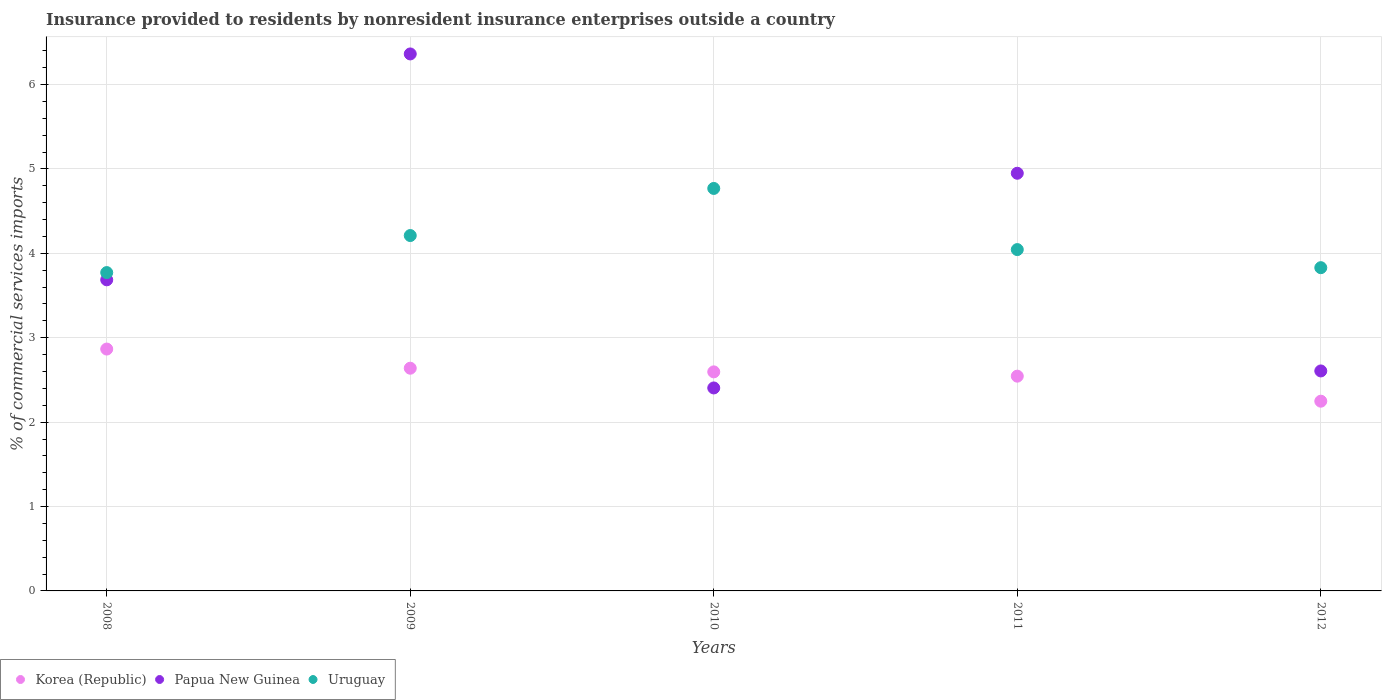How many different coloured dotlines are there?
Give a very brief answer. 3. What is the Insurance provided to residents in Korea (Republic) in 2011?
Provide a succinct answer. 2.54. Across all years, what is the maximum Insurance provided to residents in Papua New Guinea?
Offer a very short reply. 6.36. Across all years, what is the minimum Insurance provided to residents in Uruguay?
Offer a terse response. 3.77. In which year was the Insurance provided to residents in Uruguay maximum?
Make the answer very short. 2010. In which year was the Insurance provided to residents in Papua New Guinea minimum?
Ensure brevity in your answer.  2010. What is the total Insurance provided to residents in Papua New Guinea in the graph?
Offer a very short reply. 20.01. What is the difference between the Insurance provided to residents in Uruguay in 2009 and that in 2010?
Your answer should be compact. -0.56. What is the difference between the Insurance provided to residents in Korea (Republic) in 2008 and the Insurance provided to residents in Papua New Guinea in 2012?
Offer a very short reply. 0.26. What is the average Insurance provided to residents in Uruguay per year?
Provide a short and direct response. 4.13. In the year 2012, what is the difference between the Insurance provided to residents in Korea (Republic) and Insurance provided to residents in Uruguay?
Give a very brief answer. -1.58. What is the ratio of the Insurance provided to residents in Papua New Guinea in 2009 to that in 2010?
Provide a succinct answer. 2.65. Is the difference between the Insurance provided to residents in Korea (Republic) in 2009 and 2012 greater than the difference between the Insurance provided to residents in Uruguay in 2009 and 2012?
Offer a terse response. Yes. What is the difference between the highest and the second highest Insurance provided to residents in Papua New Guinea?
Keep it short and to the point. 1.41. What is the difference between the highest and the lowest Insurance provided to residents in Uruguay?
Your answer should be very brief. 1. In how many years, is the Insurance provided to residents in Papua New Guinea greater than the average Insurance provided to residents in Papua New Guinea taken over all years?
Your answer should be very brief. 2. Is the sum of the Insurance provided to residents in Korea (Republic) in 2009 and 2012 greater than the maximum Insurance provided to residents in Papua New Guinea across all years?
Ensure brevity in your answer.  No. What is the difference between two consecutive major ticks on the Y-axis?
Give a very brief answer. 1. Are the values on the major ticks of Y-axis written in scientific E-notation?
Ensure brevity in your answer.  No. Does the graph contain grids?
Offer a terse response. Yes. How many legend labels are there?
Offer a very short reply. 3. How are the legend labels stacked?
Ensure brevity in your answer.  Horizontal. What is the title of the graph?
Provide a succinct answer. Insurance provided to residents by nonresident insurance enterprises outside a country. Does "Sweden" appear as one of the legend labels in the graph?
Keep it short and to the point. No. What is the label or title of the X-axis?
Your response must be concise. Years. What is the label or title of the Y-axis?
Your answer should be compact. % of commercial services imports. What is the % of commercial services imports in Korea (Republic) in 2008?
Offer a very short reply. 2.87. What is the % of commercial services imports in Papua New Guinea in 2008?
Offer a very short reply. 3.69. What is the % of commercial services imports in Uruguay in 2008?
Offer a very short reply. 3.77. What is the % of commercial services imports in Korea (Republic) in 2009?
Give a very brief answer. 2.64. What is the % of commercial services imports in Papua New Guinea in 2009?
Your answer should be very brief. 6.36. What is the % of commercial services imports of Uruguay in 2009?
Your answer should be very brief. 4.21. What is the % of commercial services imports of Korea (Republic) in 2010?
Make the answer very short. 2.6. What is the % of commercial services imports in Papua New Guinea in 2010?
Make the answer very short. 2.4. What is the % of commercial services imports of Uruguay in 2010?
Your answer should be compact. 4.77. What is the % of commercial services imports of Korea (Republic) in 2011?
Your response must be concise. 2.54. What is the % of commercial services imports in Papua New Guinea in 2011?
Your answer should be very brief. 4.95. What is the % of commercial services imports of Uruguay in 2011?
Your answer should be very brief. 4.04. What is the % of commercial services imports of Korea (Republic) in 2012?
Ensure brevity in your answer.  2.25. What is the % of commercial services imports of Papua New Guinea in 2012?
Your response must be concise. 2.61. What is the % of commercial services imports in Uruguay in 2012?
Make the answer very short. 3.83. Across all years, what is the maximum % of commercial services imports in Korea (Republic)?
Give a very brief answer. 2.87. Across all years, what is the maximum % of commercial services imports in Papua New Guinea?
Your answer should be compact. 6.36. Across all years, what is the maximum % of commercial services imports in Uruguay?
Ensure brevity in your answer.  4.77. Across all years, what is the minimum % of commercial services imports of Korea (Republic)?
Your answer should be very brief. 2.25. Across all years, what is the minimum % of commercial services imports in Papua New Guinea?
Give a very brief answer. 2.4. Across all years, what is the minimum % of commercial services imports of Uruguay?
Make the answer very short. 3.77. What is the total % of commercial services imports of Korea (Republic) in the graph?
Offer a terse response. 12.89. What is the total % of commercial services imports in Papua New Guinea in the graph?
Your response must be concise. 20.01. What is the total % of commercial services imports of Uruguay in the graph?
Keep it short and to the point. 20.63. What is the difference between the % of commercial services imports of Korea (Republic) in 2008 and that in 2009?
Keep it short and to the point. 0.23. What is the difference between the % of commercial services imports of Papua New Guinea in 2008 and that in 2009?
Provide a short and direct response. -2.68. What is the difference between the % of commercial services imports in Uruguay in 2008 and that in 2009?
Your response must be concise. -0.44. What is the difference between the % of commercial services imports in Korea (Republic) in 2008 and that in 2010?
Your response must be concise. 0.27. What is the difference between the % of commercial services imports in Papua New Guinea in 2008 and that in 2010?
Provide a short and direct response. 1.28. What is the difference between the % of commercial services imports in Uruguay in 2008 and that in 2010?
Keep it short and to the point. -1. What is the difference between the % of commercial services imports of Korea (Republic) in 2008 and that in 2011?
Give a very brief answer. 0.32. What is the difference between the % of commercial services imports of Papua New Guinea in 2008 and that in 2011?
Provide a short and direct response. -1.26. What is the difference between the % of commercial services imports of Uruguay in 2008 and that in 2011?
Your answer should be compact. -0.27. What is the difference between the % of commercial services imports of Korea (Republic) in 2008 and that in 2012?
Give a very brief answer. 0.62. What is the difference between the % of commercial services imports of Papua New Guinea in 2008 and that in 2012?
Your response must be concise. 1.08. What is the difference between the % of commercial services imports of Uruguay in 2008 and that in 2012?
Keep it short and to the point. -0.06. What is the difference between the % of commercial services imports of Korea (Republic) in 2009 and that in 2010?
Make the answer very short. 0.04. What is the difference between the % of commercial services imports in Papua New Guinea in 2009 and that in 2010?
Offer a very short reply. 3.96. What is the difference between the % of commercial services imports of Uruguay in 2009 and that in 2010?
Offer a very short reply. -0.56. What is the difference between the % of commercial services imports in Korea (Republic) in 2009 and that in 2011?
Your response must be concise. 0.09. What is the difference between the % of commercial services imports of Papua New Guinea in 2009 and that in 2011?
Make the answer very short. 1.41. What is the difference between the % of commercial services imports in Uruguay in 2009 and that in 2011?
Your answer should be compact. 0.17. What is the difference between the % of commercial services imports of Korea (Republic) in 2009 and that in 2012?
Provide a succinct answer. 0.39. What is the difference between the % of commercial services imports in Papua New Guinea in 2009 and that in 2012?
Ensure brevity in your answer.  3.76. What is the difference between the % of commercial services imports of Uruguay in 2009 and that in 2012?
Ensure brevity in your answer.  0.38. What is the difference between the % of commercial services imports in Korea (Republic) in 2010 and that in 2011?
Make the answer very short. 0.05. What is the difference between the % of commercial services imports of Papua New Guinea in 2010 and that in 2011?
Your answer should be compact. -2.54. What is the difference between the % of commercial services imports of Uruguay in 2010 and that in 2011?
Ensure brevity in your answer.  0.72. What is the difference between the % of commercial services imports in Korea (Republic) in 2010 and that in 2012?
Ensure brevity in your answer.  0.35. What is the difference between the % of commercial services imports of Papua New Guinea in 2010 and that in 2012?
Give a very brief answer. -0.2. What is the difference between the % of commercial services imports of Uruguay in 2010 and that in 2012?
Your answer should be compact. 0.94. What is the difference between the % of commercial services imports of Korea (Republic) in 2011 and that in 2012?
Make the answer very short. 0.3. What is the difference between the % of commercial services imports in Papua New Guinea in 2011 and that in 2012?
Make the answer very short. 2.34. What is the difference between the % of commercial services imports of Uruguay in 2011 and that in 2012?
Your answer should be compact. 0.21. What is the difference between the % of commercial services imports in Korea (Republic) in 2008 and the % of commercial services imports in Papua New Guinea in 2009?
Ensure brevity in your answer.  -3.5. What is the difference between the % of commercial services imports in Korea (Republic) in 2008 and the % of commercial services imports in Uruguay in 2009?
Make the answer very short. -1.34. What is the difference between the % of commercial services imports of Papua New Guinea in 2008 and the % of commercial services imports of Uruguay in 2009?
Your response must be concise. -0.52. What is the difference between the % of commercial services imports of Korea (Republic) in 2008 and the % of commercial services imports of Papua New Guinea in 2010?
Offer a terse response. 0.46. What is the difference between the % of commercial services imports in Korea (Republic) in 2008 and the % of commercial services imports in Uruguay in 2010?
Your answer should be very brief. -1.9. What is the difference between the % of commercial services imports of Papua New Guinea in 2008 and the % of commercial services imports of Uruguay in 2010?
Offer a terse response. -1.08. What is the difference between the % of commercial services imports in Korea (Republic) in 2008 and the % of commercial services imports in Papua New Guinea in 2011?
Your answer should be very brief. -2.08. What is the difference between the % of commercial services imports in Korea (Republic) in 2008 and the % of commercial services imports in Uruguay in 2011?
Keep it short and to the point. -1.18. What is the difference between the % of commercial services imports in Papua New Guinea in 2008 and the % of commercial services imports in Uruguay in 2011?
Your answer should be compact. -0.36. What is the difference between the % of commercial services imports of Korea (Republic) in 2008 and the % of commercial services imports of Papua New Guinea in 2012?
Offer a very short reply. 0.26. What is the difference between the % of commercial services imports in Korea (Republic) in 2008 and the % of commercial services imports in Uruguay in 2012?
Provide a succinct answer. -0.96. What is the difference between the % of commercial services imports in Papua New Guinea in 2008 and the % of commercial services imports in Uruguay in 2012?
Offer a terse response. -0.14. What is the difference between the % of commercial services imports of Korea (Republic) in 2009 and the % of commercial services imports of Papua New Guinea in 2010?
Your answer should be compact. 0.23. What is the difference between the % of commercial services imports in Korea (Republic) in 2009 and the % of commercial services imports in Uruguay in 2010?
Your answer should be very brief. -2.13. What is the difference between the % of commercial services imports in Papua New Guinea in 2009 and the % of commercial services imports in Uruguay in 2010?
Your response must be concise. 1.59. What is the difference between the % of commercial services imports in Korea (Republic) in 2009 and the % of commercial services imports in Papua New Guinea in 2011?
Make the answer very short. -2.31. What is the difference between the % of commercial services imports of Korea (Republic) in 2009 and the % of commercial services imports of Uruguay in 2011?
Provide a succinct answer. -1.41. What is the difference between the % of commercial services imports in Papua New Guinea in 2009 and the % of commercial services imports in Uruguay in 2011?
Your answer should be compact. 2.32. What is the difference between the % of commercial services imports in Korea (Republic) in 2009 and the % of commercial services imports in Papua New Guinea in 2012?
Your response must be concise. 0.03. What is the difference between the % of commercial services imports of Korea (Republic) in 2009 and the % of commercial services imports of Uruguay in 2012?
Give a very brief answer. -1.19. What is the difference between the % of commercial services imports of Papua New Guinea in 2009 and the % of commercial services imports of Uruguay in 2012?
Provide a short and direct response. 2.53. What is the difference between the % of commercial services imports in Korea (Republic) in 2010 and the % of commercial services imports in Papua New Guinea in 2011?
Ensure brevity in your answer.  -2.35. What is the difference between the % of commercial services imports of Korea (Republic) in 2010 and the % of commercial services imports of Uruguay in 2011?
Ensure brevity in your answer.  -1.45. What is the difference between the % of commercial services imports of Papua New Guinea in 2010 and the % of commercial services imports of Uruguay in 2011?
Your answer should be compact. -1.64. What is the difference between the % of commercial services imports of Korea (Republic) in 2010 and the % of commercial services imports of Papua New Guinea in 2012?
Give a very brief answer. -0.01. What is the difference between the % of commercial services imports in Korea (Republic) in 2010 and the % of commercial services imports in Uruguay in 2012?
Keep it short and to the point. -1.23. What is the difference between the % of commercial services imports of Papua New Guinea in 2010 and the % of commercial services imports of Uruguay in 2012?
Your answer should be compact. -1.43. What is the difference between the % of commercial services imports of Korea (Republic) in 2011 and the % of commercial services imports of Papua New Guinea in 2012?
Provide a short and direct response. -0.06. What is the difference between the % of commercial services imports of Korea (Republic) in 2011 and the % of commercial services imports of Uruguay in 2012?
Offer a terse response. -1.29. What is the difference between the % of commercial services imports in Papua New Guinea in 2011 and the % of commercial services imports in Uruguay in 2012?
Offer a very short reply. 1.12. What is the average % of commercial services imports of Korea (Republic) per year?
Give a very brief answer. 2.58. What is the average % of commercial services imports of Papua New Guinea per year?
Give a very brief answer. 4. What is the average % of commercial services imports of Uruguay per year?
Offer a terse response. 4.13. In the year 2008, what is the difference between the % of commercial services imports in Korea (Republic) and % of commercial services imports in Papua New Guinea?
Keep it short and to the point. -0.82. In the year 2008, what is the difference between the % of commercial services imports in Korea (Republic) and % of commercial services imports in Uruguay?
Provide a short and direct response. -0.91. In the year 2008, what is the difference between the % of commercial services imports of Papua New Guinea and % of commercial services imports of Uruguay?
Give a very brief answer. -0.09. In the year 2009, what is the difference between the % of commercial services imports in Korea (Republic) and % of commercial services imports in Papua New Guinea?
Offer a terse response. -3.72. In the year 2009, what is the difference between the % of commercial services imports of Korea (Republic) and % of commercial services imports of Uruguay?
Provide a short and direct response. -1.57. In the year 2009, what is the difference between the % of commercial services imports in Papua New Guinea and % of commercial services imports in Uruguay?
Offer a terse response. 2.15. In the year 2010, what is the difference between the % of commercial services imports in Korea (Republic) and % of commercial services imports in Papua New Guinea?
Offer a very short reply. 0.19. In the year 2010, what is the difference between the % of commercial services imports in Korea (Republic) and % of commercial services imports in Uruguay?
Provide a succinct answer. -2.17. In the year 2010, what is the difference between the % of commercial services imports in Papua New Guinea and % of commercial services imports in Uruguay?
Your answer should be very brief. -2.36. In the year 2011, what is the difference between the % of commercial services imports of Korea (Republic) and % of commercial services imports of Papua New Guinea?
Offer a very short reply. -2.4. In the year 2011, what is the difference between the % of commercial services imports in Korea (Republic) and % of commercial services imports in Uruguay?
Provide a succinct answer. -1.5. In the year 2011, what is the difference between the % of commercial services imports in Papua New Guinea and % of commercial services imports in Uruguay?
Your answer should be compact. 0.9. In the year 2012, what is the difference between the % of commercial services imports of Korea (Republic) and % of commercial services imports of Papua New Guinea?
Give a very brief answer. -0.36. In the year 2012, what is the difference between the % of commercial services imports of Korea (Republic) and % of commercial services imports of Uruguay?
Provide a succinct answer. -1.58. In the year 2012, what is the difference between the % of commercial services imports in Papua New Guinea and % of commercial services imports in Uruguay?
Provide a short and direct response. -1.22. What is the ratio of the % of commercial services imports of Korea (Republic) in 2008 to that in 2009?
Provide a succinct answer. 1.09. What is the ratio of the % of commercial services imports in Papua New Guinea in 2008 to that in 2009?
Keep it short and to the point. 0.58. What is the ratio of the % of commercial services imports of Uruguay in 2008 to that in 2009?
Your answer should be very brief. 0.9. What is the ratio of the % of commercial services imports in Korea (Republic) in 2008 to that in 2010?
Ensure brevity in your answer.  1.1. What is the ratio of the % of commercial services imports of Papua New Guinea in 2008 to that in 2010?
Provide a short and direct response. 1.53. What is the ratio of the % of commercial services imports of Uruguay in 2008 to that in 2010?
Your answer should be very brief. 0.79. What is the ratio of the % of commercial services imports in Korea (Republic) in 2008 to that in 2011?
Your answer should be compact. 1.13. What is the ratio of the % of commercial services imports in Papua New Guinea in 2008 to that in 2011?
Offer a terse response. 0.74. What is the ratio of the % of commercial services imports of Uruguay in 2008 to that in 2011?
Your answer should be compact. 0.93. What is the ratio of the % of commercial services imports of Korea (Republic) in 2008 to that in 2012?
Your answer should be very brief. 1.27. What is the ratio of the % of commercial services imports in Papua New Guinea in 2008 to that in 2012?
Offer a very short reply. 1.41. What is the ratio of the % of commercial services imports in Uruguay in 2008 to that in 2012?
Provide a succinct answer. 0.98. What is the ratio of the % of commercial services imports in Korea (Republic) in 2009 to that in 2010?
Keep it short and to the point. 1.02. What is the ratio of the % of commercial services imports in Papua New Guinea in 2009 to that in 2010?
Your answer should be very brief. 2.65. What is the ratio of the % of commercial services imports in Uruguay in 2009 to that in 2010?
Offer a very short reply. 0.88. What is the ratio of the % of commercial services imports of Korea (Republic) in 2009 to that in 2011?
Give a very brief answer. 1.04. What is the ratio of the % of commercial services imports in Papua New Guinea in 2009 to that in 2011?
Make the answer very short. 1.29. What is the ratio of the % of commercial services imports of Uruguay in 2009 to that in 2011?
Your response must be concise. 1.04. What is the ratio of the % of commercial services imports of Korea (Republic) in 2009 to that in 2012?
Give a very brief answer. 1.17. What is the ratio of the % of commercial services imports of Papua New Guinea in 2009 to that in 2012?
Your answer should be compact. 2.44. What is the ratio of the % of commercial services imports in Uruguay in 2009 to that in 2012?
Provide a succinct answer. 1.1. What is the ratio of the % of commercial services imports in Korea (Republic) in 2010 to that in 2011?
Your response must be concise. 1.02. What is the ratio of the % of commercial services imports of Papua New Guinea in 2010 to that in 2011?
Keep it short and to the point. 0.49. What is the ratio of the % of commercial services imports of Uruguay in 2010 to that in 2011?
Your answer should be very brief. 1.18. What is the ratio of the % of commercial services imports of Korea (Republic) in 2010 to that in 2012?
Offer a terse response. 1.15. What is the ratio of the % of commercial services imports in Papua New Guinea in 2010 to that in 2012?
Provide a short and direct response. 0.92. What is the ratio of the % of commercial services imports of Uruguay in 2010 to that in 2012?
Your answer should be compact. 1.25. What is the ratio of the % of commercial services imports in Korea (Republic) in 2011 to that in 2012?
Make the answer very short. 1.13. What is the ratio of the % of commercial services imports in Papua New Guinea in 2011 to that in 2012?
Provide a succinct answer. 1.9. What is the ratio of the % of commercial services imports in Uruguay in 2011 to that in 2012?
Provide a succinct answer. 1.06. What is the difference between the highest and the second highest % of commercial services imports in Korea (Republic)?
Provide a succinct answer. 0.23. What is the difference between the highest and the second highest % of commercial services imports of Papua New Guinea?
Your answer should be very brief. 1.41. What is the difference between the highest and the second highest % of commercial services imports in Uruguay?
Keep it short and to the point. 0.56. What is the difference between the highest and the lowest % of commercial services imports of Korea (Republic)?
Give a very brief answer. 0.62. What is the difference between the highest and the lowest % of commercial services imports of Papua New Guinea?
Give a very brief answer. 3.96. 